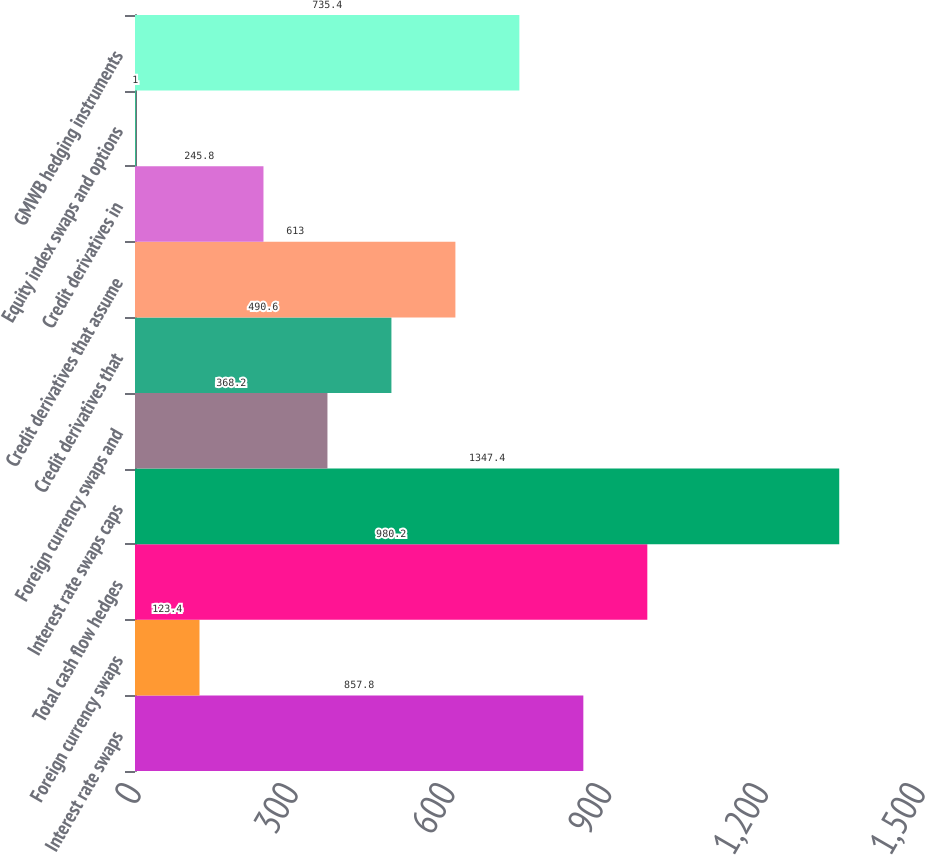Convert chart to OTSL. <chart><loc_0><loc_0><loc_500><loc_500><bar_chart><fcel>Interest rate swaps<fcel>Foreign currency swaps<fcel>Total cash flow hedges<fcel>Interest rate swaps caps<fcel>Foreign currency swaps and<fcel>Credit derivatives that<fcel>Credit derivatives that assume<fcel>Credit derivatives in<fcel>Equity index swaps and options<fcel>GMWB hedging instruments<nl><fcel>857.8<fcel>123.4<fcel>980.2<fcel>1347.4<fcel>368.2<fcel>490.6<fcel>613<fcel>245.8<fcel>1<fcel>735.4<nl></chart> 